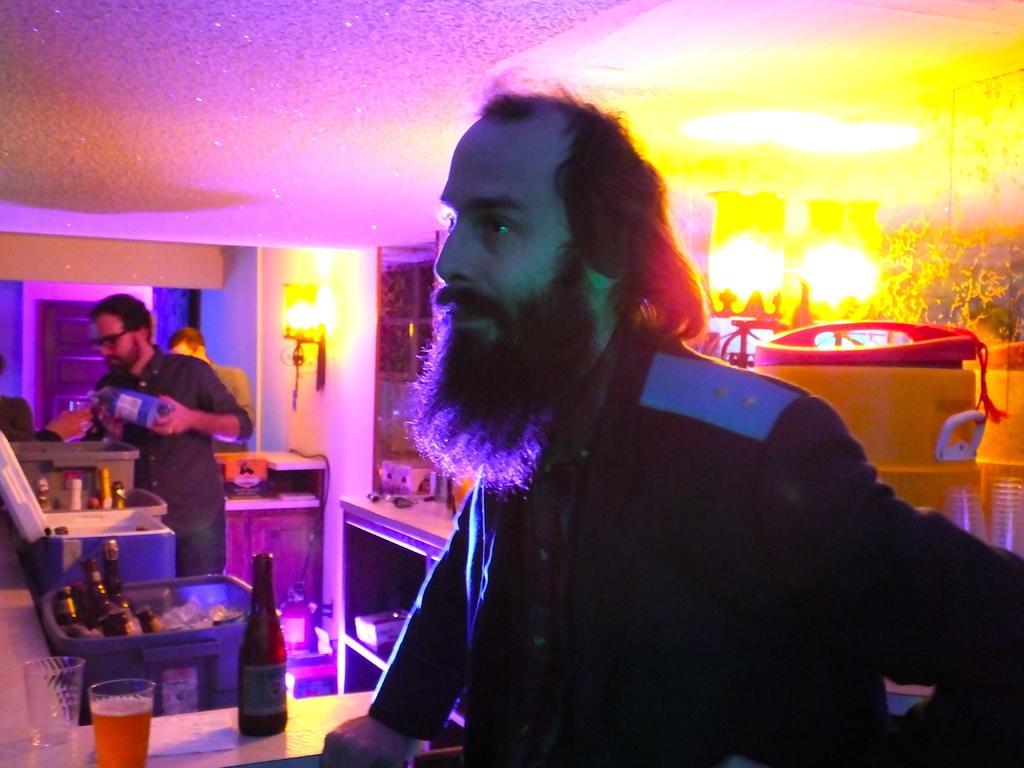Can you describe this image briefly? In this image, we can see persons wearing clothes. There is a person on the left side of the image holding a bottle with his hand. There is table in the bottom left of the image contains bottle and glasses. There is a drum on the right side of the image. There are containers contains bottles. There is a light on the wall. There is a ceiling at the top of the image. 